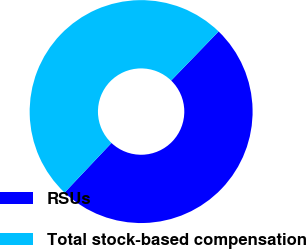Convert chart to OTSL. <chart><loc_0><loc_0><loc_500><loc_500><pie_chart><fcel>RSUs<fcel>Total stock-based compensation<nl><fcel>49.82%<fcel>50.18%<nl></chart> 